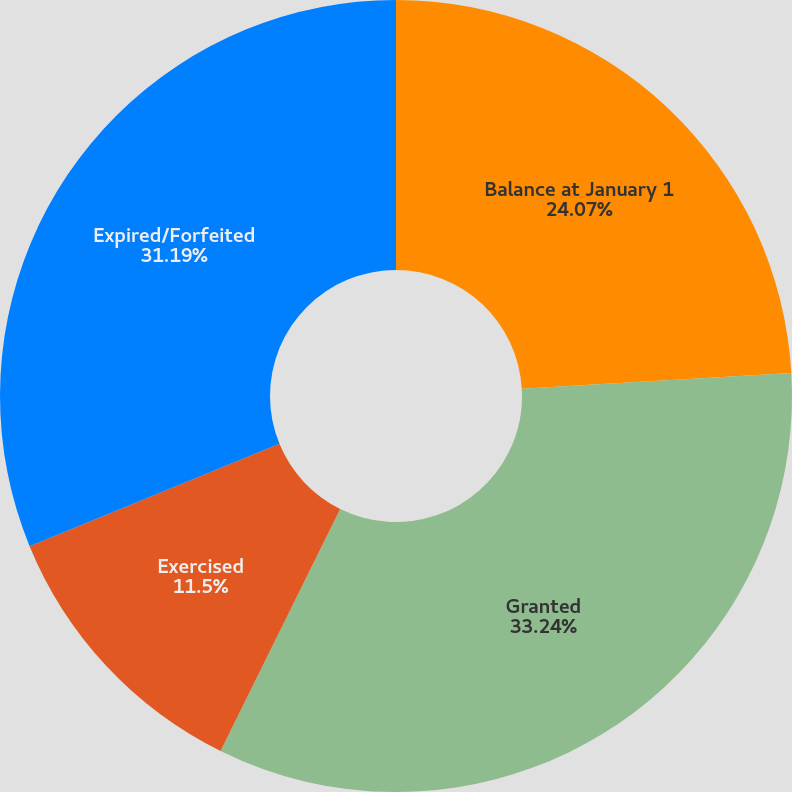Convert chart. <chart><loc_0><loc_0><loc_500><loc_500><pie_chart><fcel>Balance at January 1<fcel>Granted<fcel>Exercised<fcel>Expired/Forfeited<nl><fcel>24.07%<fcel>33.23%<fcel>11.5%<fcel>31.19%<nl></chart> 